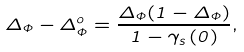Convert formula to latex. <formula><loc_0><loc_0><loc_500><loc_500>\Delta _ { \Phi } - \Delta ^ { o } _ { \Phi } = \frac { \Delta _ { \Phi } ( 1 - \Delta _ { \Phi } ) } { 1 - \gamma _ { s } \left ( 0 \right ) } ,</formula> 